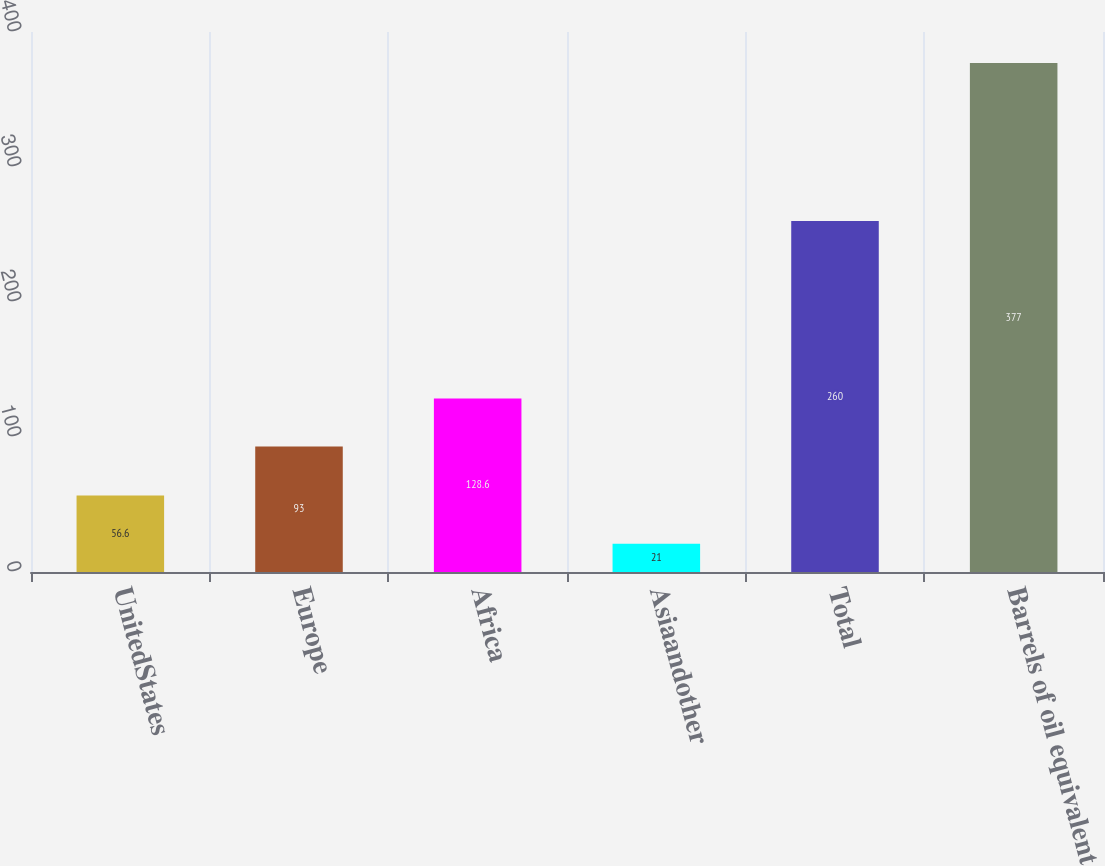Convert chart. <chart><loc_0><loc_0><loc_500><loc_500><bar_chart><fcel>UnitedStates<fcel>Europe<fcel>Africa<fcel>Asiaandother<fcel>Total<fcel>Barrels of oil equivalent<nl><fcel>56.6<fcel>93<fcel>128.6<fcel>21<fcel>260<fcel>377<nl></chart> 